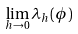<formula> <loc_0><loc_0><loc_500><loc_500>\lim _ { h \to 0 } \lambda _ { h } ( \phi )</formula> 